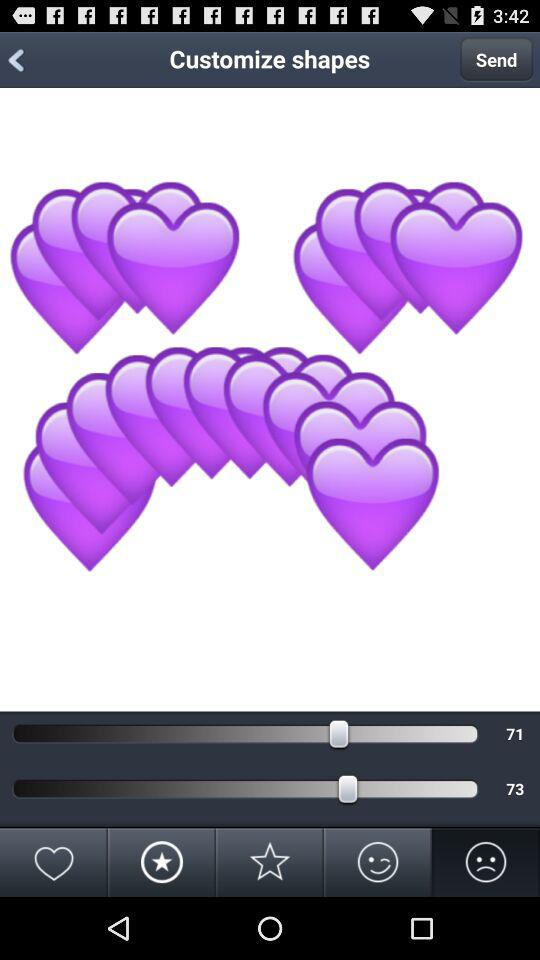What is the current level of brightness?
When the provided information is insufficient, respond with <no answer>. <no answer> 